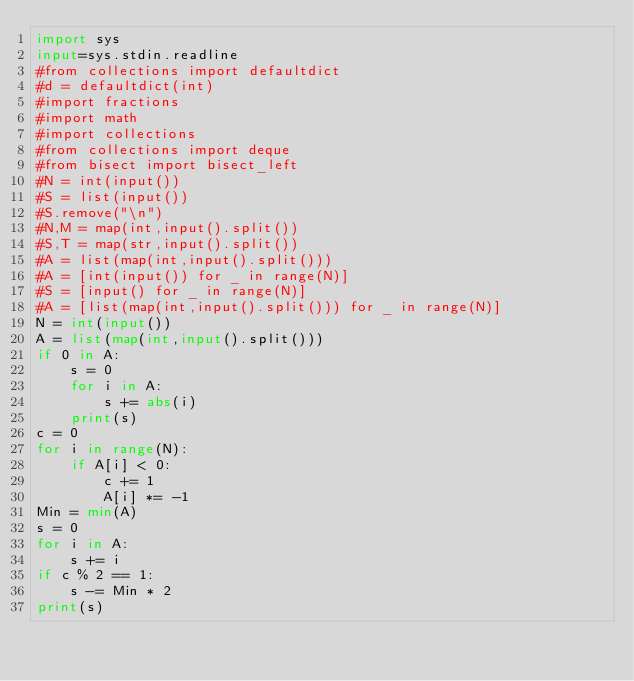<code> <loc_0><loc_0><loc_500><loc_500><_Python_>import sys
input=sys.stdin.readline
#from collections import defaultdict
#d = defaultdict(int)
#import fractions
#import math
#import collections
#from collections import deque
#from bisect import bisect_left
#N = int(input())
#S = list(input())
#S.remove("\n")
#N,M = map(int,input().split())
#S,T = map(str,input().split())
#A = list(map(int,input().split()))
#A = [int(input()) for _ in range(N)]
#S = [input() for _ in range(N)]
#A = [list(map(int,input().split())) for _ in range(N)]
N = int(input())
A = list(map(int,input().split()))
if 0 in A:
    s = 0
    for i in A:
        s += abs(i)
    print(s)
c = 0
for i in range(N):
    if A[i] < 0:
        c += 1
        A[i] *= -1
Min = min(A)
s = 0
for i in A:
    s += i
if c % 2 == 1:
    s -= Min * 2
print(s)</code> 